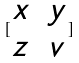<formula> <loc_0><loc_0><loc_500><loc_500>[ \begin{matrix} x & y \\ z & v \end{matrix} ]</formula> 